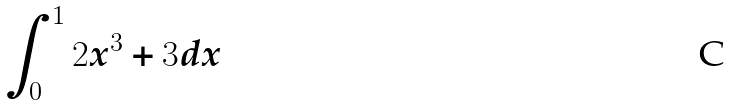Convert formula to latex. <formula><loc_0><loc_0><loc_500><loc_500>\int _ { 0 } ^ { 1 } 2 x ^ { 3 } + 3 d x</formula> 